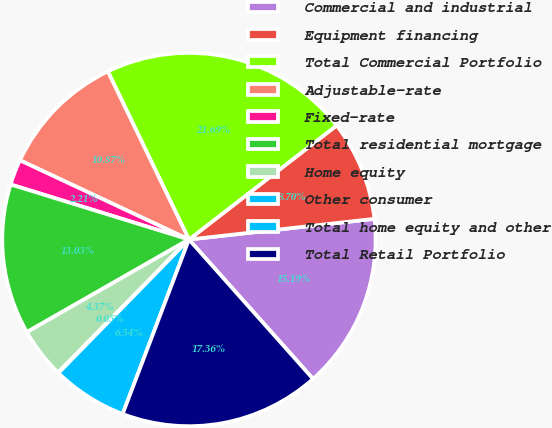<chart> <loc_0><loc_0><loc_500><loc_500><pie_chart><fcel>Commercial and industrial<fcel>Equipment financing<fcel>Total Commercial Portfolio<fcel>Adjustable-rate<fcel>Fixed-rate<fcel>Total residential mortgage<fcel>Home equity<fcel>Other consumer<fcel>Total home equity and other<fcel>Total Retail Portfolio<nl><fcel>15.19%<fcel>8.7%<fcel>21.69%<fcel>10.87%<fcel>2.21%<fcel>13.03%<fcel>4.37%<fcel>0.05%<fcel>6.54%<fcel>17.36%<nl></chart> 